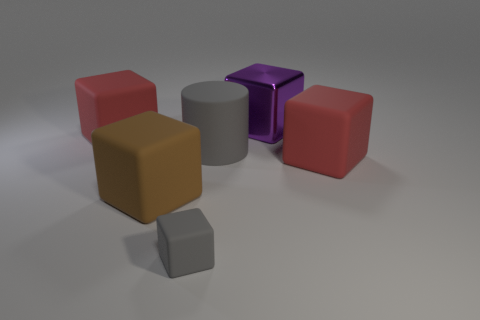How big is the brown rubber thing?
Ensure brevity in your answer.  Large. What number of objects are large brown objects or gray cylinders?
Provide a short and direct response. 2. What is the color of the cylinder that is the same material as the brown cube?
Give a very brief answer. Gray. There is a big rubber object right of the shiny thing; is its shape the same as the purple metal object?
Offer a very short reply. Yes. What number of objects are red matte objects in front of the matte cylinder or large blocks that are behind the matte cylinder?
Ensure brevity in your answer.  3. What is the color of the tiny thing that is the same shape as the big brown thing?
Provide a short and direct response. Gray. Are there any other things that are the same shape as the large gray thing?
Offer a very short reply. No. There is a big purple shiny object; does it have the same shape as the gray object that is in front of the big gray rubber cylinder?
Ensure brevity in your answer.  Yes. What material is the large brown thing?
Ensure brevity in your answer.  Rubber. What is the size of the gray rubber object that is the same shape as the brown rubber thing?
Your response must be concise. Small. 